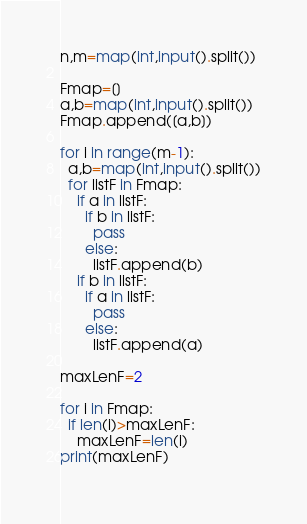<code> <loc_0><loc_0><loc_500><loc_500><_Python_>n,m=map(int,input().split())

Fmap=[]
a,b=map(int,input().split())
Fmap.append([a,b])

for i in range(m-1):
  a,b=map(int,input().split())
  for listF in Fmap:
    if a in listF:
      if b in listF:
        pass
      else:
        listF.append(b)
    if b in listF:
      if a in listF:
      	pass
      else:
        listF.append(a)

maxLenF=2

for i in Fmap:
  if len(i)>maxLenF:
    maxLenF=len(i)
print(maxLenF)
  </code> 